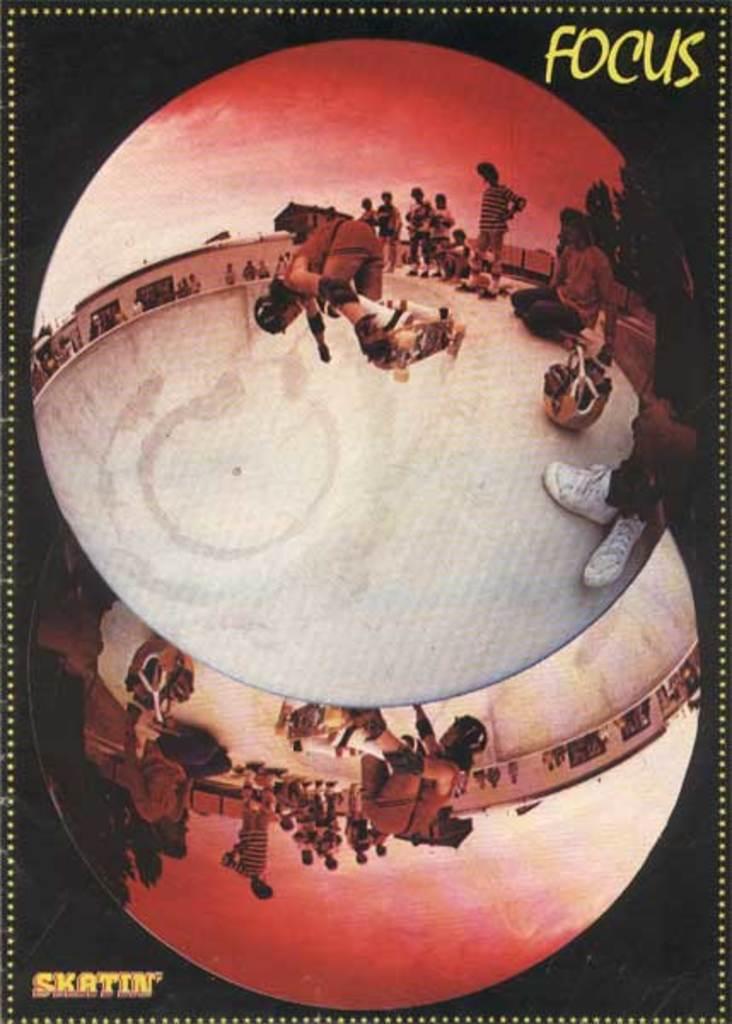Focus on what?
Provide a succinct answer. Skatin. 